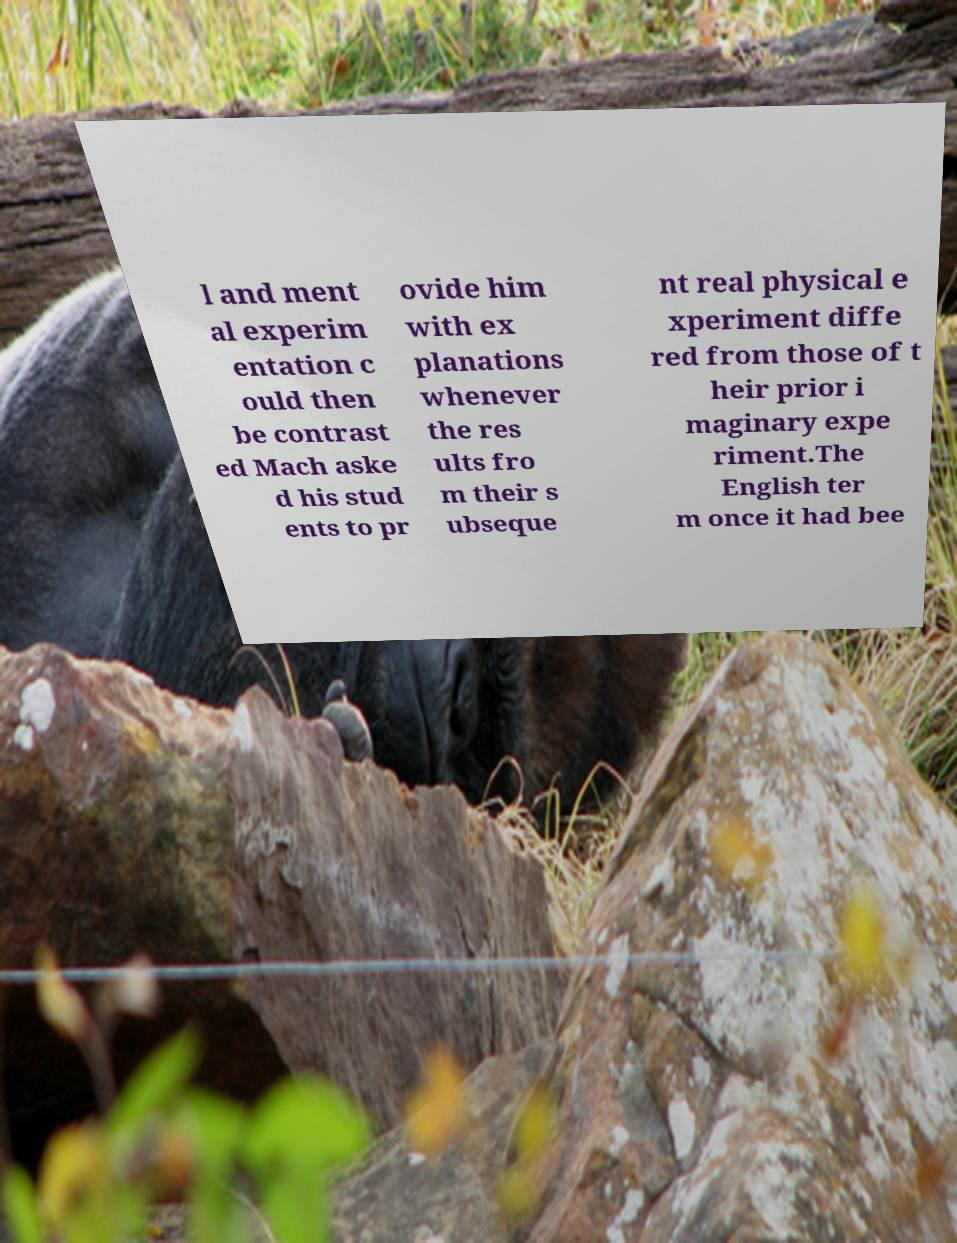I need the written content from this picture converted into text. Can you do that? l and ment al experim entation c ould then be contrast ed Mach aske d his stud ents to pr ovide him with ex planations whenever the res ults fro m their s ubseque nt real physical e xperiment diffe red from those of t heir prior i maginary expe riment.The English ter m once it had bee 